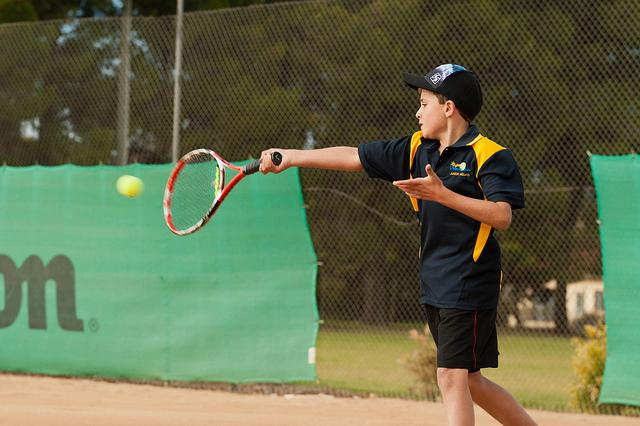Why are there letters on the green banners? Please explain your reasoning. company sponsorships. There are ads. 